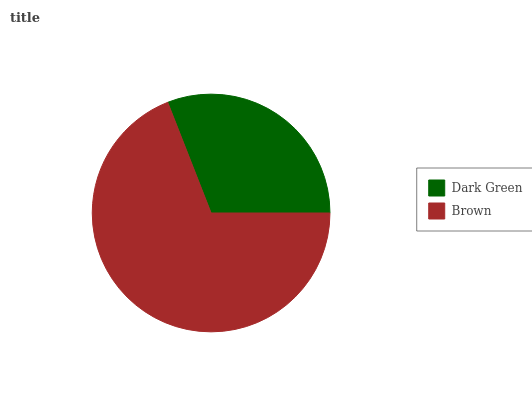Is Dark Green the minimum?
Answer yes or no. Yes. Is Brown the maximum?
Answer yes or no. Yes. Is Brown the minimum?
Answer yes or no. No. Is Brown greater than Dark Green?
Answer yes or no. Yes. Is Dark Green less than Brown?
Answer yes or no. Yes. Is Dark Green greater than Brown?
Answer yes or no. No. Is Brown less than Dark Green?
Answer yes or no. No. Is Brown the high median?
Answer yes or no. Yes. Is Dark Green the low median?
Answer yes or no. Yes. Is Dark Green the high median?
Answer yes or no. No. Is Brown the low median?
Answer yes or no. No. 